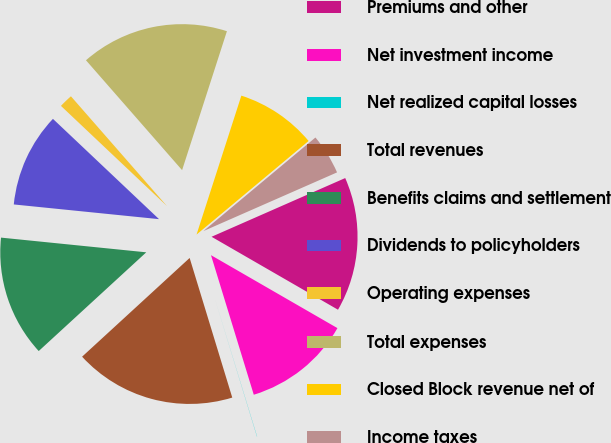<chart> <loc_0><loc_0><loc_500><loc_500><pie_chart><fcel>Premiums and other<fcel>Net investment income<fcel>Net realized capital losses<fcel>Total revenues<fcel>Benefits claims and settlement<fcel>Dividends to policyholders<fcel>Operating expenses<fcel>Total expenses<fcel>Closed Block revenue net of<fcel>Income taxes<nl><fcel>14.92%<fcel>11.94%<fcel>0.02%<fcel>17.9%<fcel>13.43%<fcel>10.45%<fcel>1.51%<fcel>16.41%<fcel>8.96%<fcel>4.49%<nl></chart> 